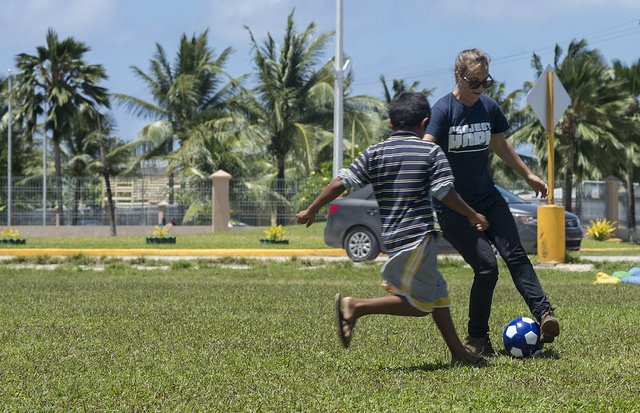Describe the objects in this image and their specific colors. I can see people in lightblue, black, gray, darkblue, and darkgreen tones, people in lightblue, black, and gray tones, car in lightblue, gray, black, and darkgray tones, and sports ball in lightblue, black, white, navy, and gray tones in this image. 